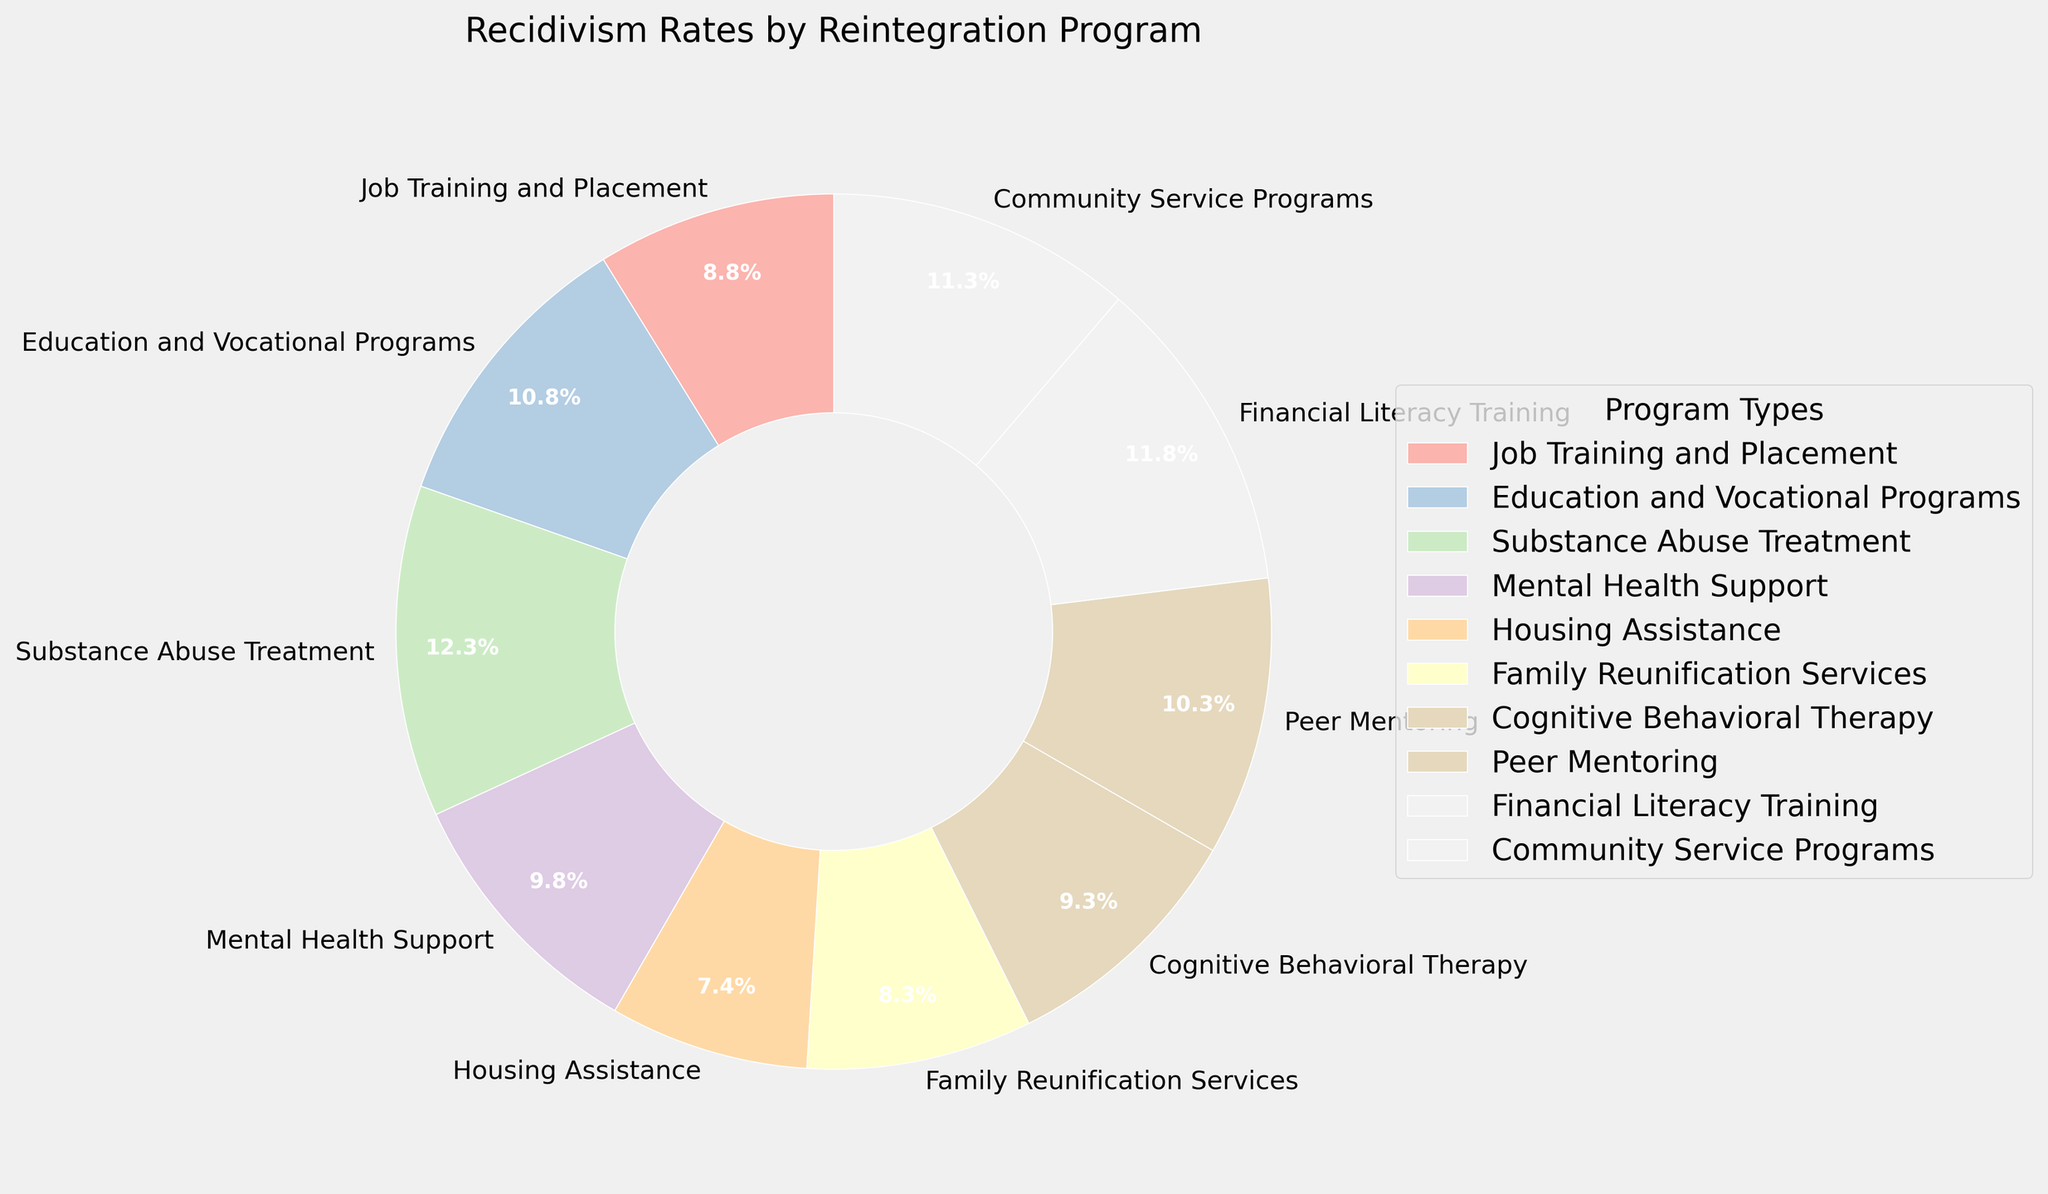Which reintegration program has the lowest recidivism rate? The lowest recidivism rate can be determined by looking at the labeled percentages in the pie chart. In this case, Housing Assistance has the lowest rate at 15%.
Answer: Housing Assistance Which reintegration program has the highest recidivism rate? The highest recidivism rate can be found by identifying the largest percentage in the pie chart. Substance Abuse Treatment has the highest rate at 25%.
Answer: Substance Abuse Treatment What is the difference in recidivism rates between Job Training and Placement and Cognitive Behavioral Therapy? To find the difference, subtract the recidivism rate of Cognitive Behavioral Therapy (19%) from that of Job Training and Placement (18%). 18% - 19% = -1%.
Answer: -1% Which programs have a recidivism rate greater than 20%? By examining the pie chart, the programs with rates over 20% are Education and Vocational Programs (22%), Substance Abuse Treatment (25%), Financial Literacy Training (24%), and Community Service Programs (23%).
Answer: Education and Vocational Programs, Substance Abuse Treatment, Financial Literacy Training, Community Service Programs What is the average recidivism rate of all the reintegration programs? To calculate the average, sum all recidivism rates and divide by the number of programs. (18 + 22 + 25 + 20 + 15 + 17 + 19 + 21 + 24 + 23) / 10 = 204 / 10 = 20.4
Answer: 20.4 How much lower is the recidivism rate for Housing Assistance compared to Financial Literacy Training? Subtract the recidivism rate of Housing Assistance (15%) from that of Financial Literacy Training (24%). 24% - 15% = 9%
Answer: 9% Which reintegration program represented by a light color has a recidivism rate less than 20%? In the pie chart, all programs have a pastel color scheme. The programs with rates less than 20% are Housing Assistance (15%), Family Reunification Services (17%), Job Training and Placement (18%), and Cognitive Behavioral Therapy (19%). Any of these could be represented by a light color.
Answer: Housing Assistance, Family Reunification Services, Job Training and Placement, Cognitive Behavioral Therapy 